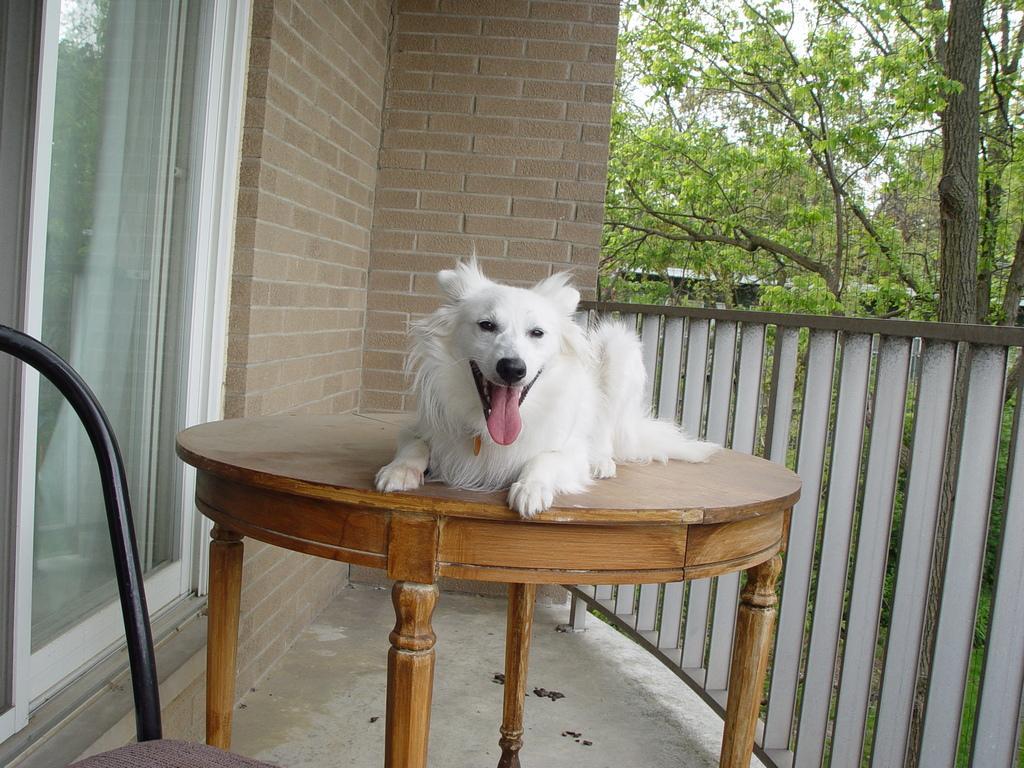Could you give a brief overview of what you see in this image? A dog is sitting on the table and the left side of an image there is a glass door behind this dog there is a brick wall on the right side there are trees and a sunny sky. 